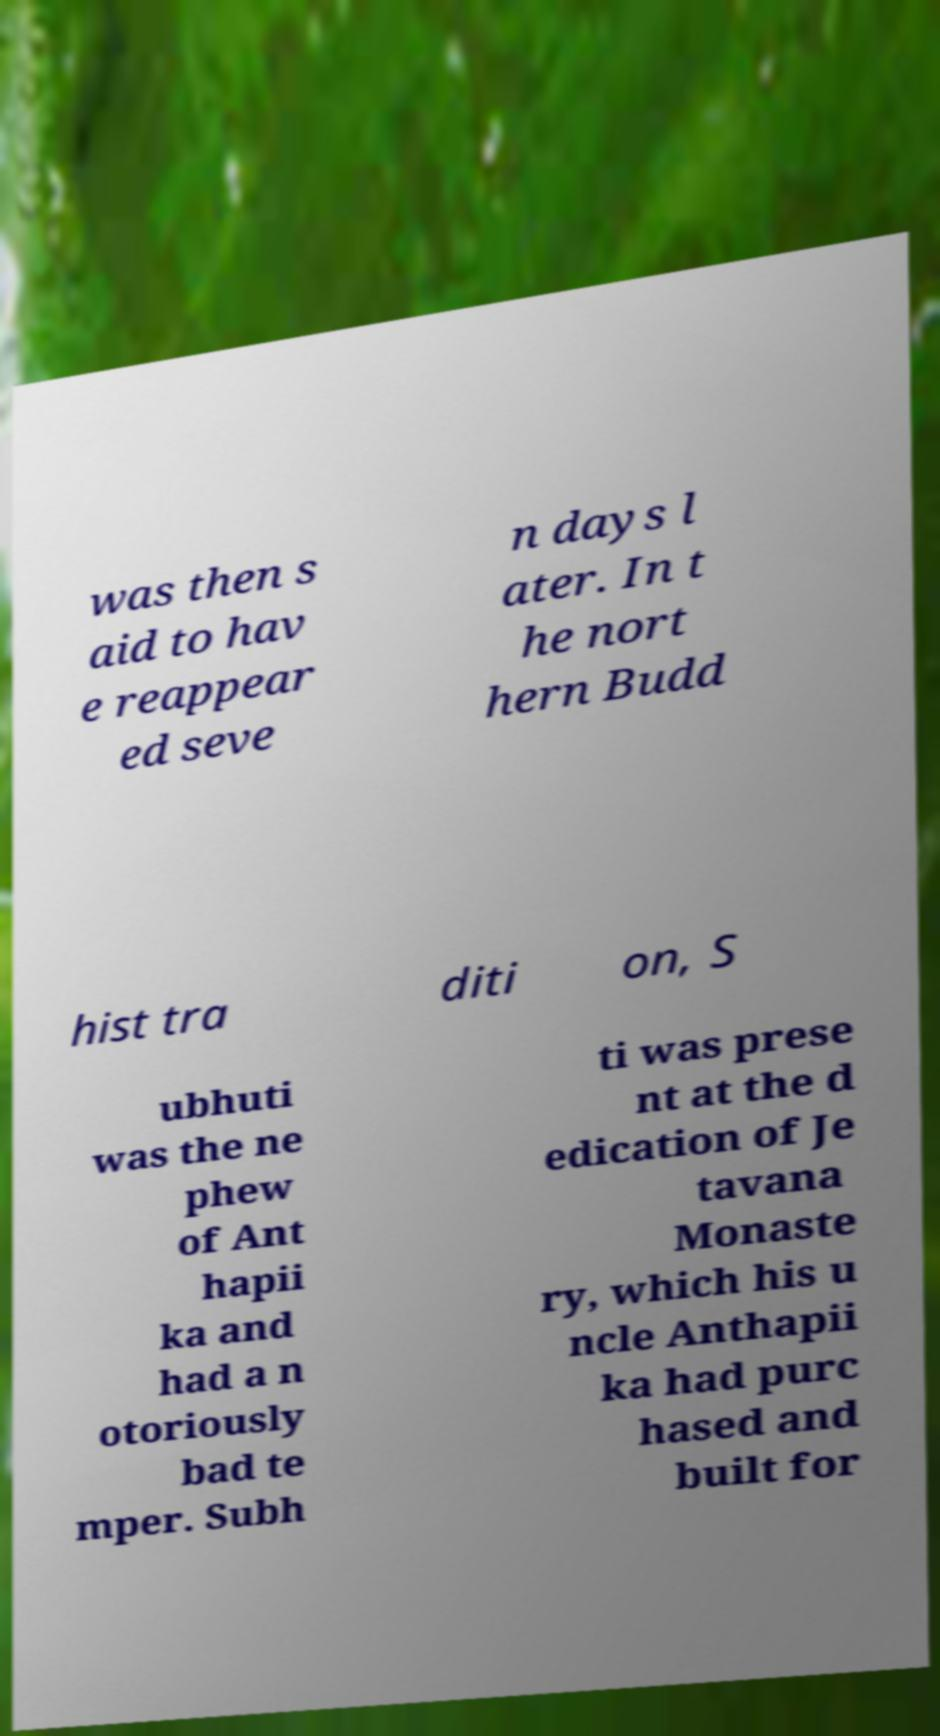Please identify and transcribe the text found in this image. was then s aid to hav e reappear ed seve n days l ater. In t he nort hern Budd hist tra diti on, S ubhuti was the ne phew of Ant hapii ka and had a n otoriously bad te mper. Subh ti was prese nt at the d edication of Je tavana Monaste ry, which his u ncle Anthapii ka had purc hased and built for 